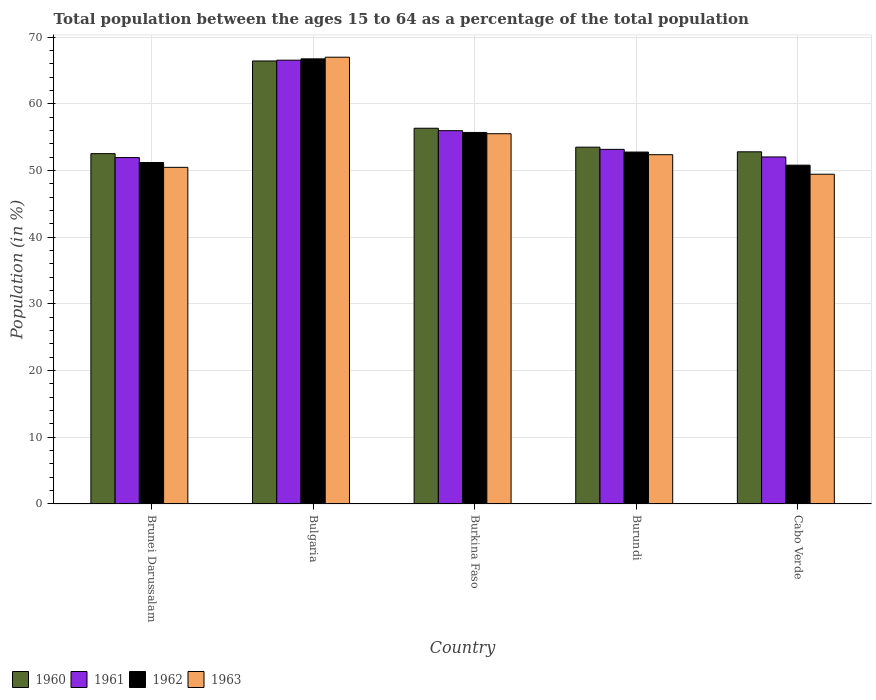How many different coloured bars are there?
Offer a very short reply. 4. Are the number of bars per tick equal to the number of legend labels?
Give a very brief answer. Yes. Are the number of bars on each tick of the X-axis equal?
Make the answer very short. Yes. What is the label of the 4th group of bars from the left?
Offer a very short reply. Burundi. What is the percentage of the population ages 15 to 64 in 1962 in Bulgaria?
Provide a short and direct response. 66.76. Across all countries, what is the maximum percentage of the population ages 15 to 64 in 1960?
Offer a very short reply. 66.44. Across all countries, what is the minimum percentage of the population ages 15 to 64 in 1960?
Offer a very short reply. 52.54. In which country was the percentage of the population ages 15 to 64 in 1962 minimum?
Keep it short and to the point. Cabo Verde. What is the total percentage of the population ages 15 to 64 in 1962 in the graph?
Provide a short and direct response. 277.27. What is the difference between the percentage of the population ages 15 to 64 in 1963 in Burkina Faso and that in Cabo Verde?
Give a very brief answer. 6.07. What is the difference between the percentage of the population ages 15 to 64 in 1963 in Brunei Darussalam and the percentage of the population ages 15 to 64 in 1960 in Burkina Faso?
Keep it short and to the point. -5.86. What is the average percentage of the population ages 15 to 64 in 1960 per country?
Make the answer very short. 56.33. What is the difference between the percentage of the population ages 15 to 64 of/in 1960 and percentage of the population ages 15 to 64 of/in 1963 in Burundi?
Your answer should be compact. 1.13. In how many countries, is the percentage of the population ages 15 to 64 in 1963 greater than 22?
Ensure brevity in your answer.  5. What is the ratio of the percentage of the population ages 15 to 64 in 1960 in Bulgaria to that in Burkina Faso?
Your answer should be very brief. 1.18. What is the difference between the highest and the second highest percentage of the population ages 15 to 64 in 1960?
Your response must be concise. -10.09. What is the difference between the highest and the lowest percentage of the population ages 15 to 64 in 1962?
Give a very brief answer. 15.94. In how many countries, is the percentage of the population ages 15 to 64 in 1963 greater than the average percentage of the population ages 15 to 64 in 1963 taken over all countries?
Keep it short and to the point. 2. Is it the case that in every country, the sum of the percentage of the population ages 15 to 64 in 1960 and percentage of the population ages 15 to 64 in 1963 is greater than the sum of percentage of the population ages 15 to 64 in 1961 and percentage of the population ages 15 to 64 in 1962?
Offer a terse response. No. What does the 1st bar from the left in Cabo Verde represents?
Your answer should be compact. 1960. What does the 3rd bar from the right in Burkina Faso represents?
Ensure brevity in your answer.  1961. Does the graph contain grids?
Your answer should be very brief. Yes. Where does the legend appear in the graph?
Give a very brief answer. Bottom left. How many legend labels are there?
Make the answer very short. 4. What is the title of the graph?
Make the answer very short. Total population between the ages 15 to 64 as a percentage of the total population. Does "1977" appear as one of the legend labels in the graph?
Your response must be concise. No. What is the Population (in %) of 1960 in Brunei Darussalam?
Keep it short and to the point. 52.54. What is the Population (in %) of 1961 in Brunei Darussalam?
Ensure brevity in your answer.  51.95. What is the Population (in %) of 1962 in Brunei Darussalam?
Provide a succinct answer. 51.21. What is the Population (in %) in 1963 in Brunei Darussalam?
Make the answer very short. 50.48. What is the Population (in %) of 1960 in Bulgaria?
Provide a succinct answer. 66.44. What is the Population (in %) in 1961 in Bulgaria?
Your answer should be very brief. 66.56. What is the Population (in %) of 1962 in Bulgaria?
Provide a short and direct response. 66.76. What is the Population (in %) of 1963 in Bulgaria?
Your answer should be compact. 67. What is the Population (in %) in 1960 in Burkina Faso?
Ensure brevity in your answer.  56.35. What is the Population (in %) in 1961 in Burkina Faso?
Make the answer very short. 55.98. What is the Population (in %) in 1962 in Burkina Faso?
Your response must be concise. 55.72. What is the Population (in %) of 1963 in Burkina Faso?
Keep it short and to the point. 55.53. What is the Population (in %) in 1960 in Burundi?
Your answer should be compact. 53.51. What is the Population (in %) of 1961 in Burundi?
Your response must be concise. 53.18. What is the Population (in %) in 1962 in Burundi?
Your response must be concise. 52.78. What is the Population (in %) in 1963 in Burundi?
Ensure brevity in your answer.  52.38. What is the Population (in %) in 1960 in Cabo Verde?
Your answer should be compact. 52.81. What is the Population (in %) of 1961 in Cabo Verde?
Your answer should be very brief. 52.04. What is the Population (in %) in 1962 in Cabo Verde?
Keep it short and to the point. 50.81. What is the Population (in %) of 1963 in Cabo Verde?
Provide a short and direct response. 49.45. Across all countries, what is the maximum Population (in %) in 1960?
Your answer should be very brief. 66.44. Across all countries, what is the maximum Population (in %) in 1961?
Offer a very short reply. 66.56. Across all countries, what is the maximum Population (in %) in 1962?
Your response must be concise. 66.76. Across all countries, what is the maximum Population (in %) in 1963?
Your answer should be compact. 67. Across all countries, what is the minimum Population (in %) in 1960?
Ensure brevity in your answer.  52.54. Across all countries, what is the minimum Population (in %) of 1961?
Your answer should be very brief. 51.95. Across all countries, what is the minimum Population (in %) in 1962?
Provide a succinct answer. 50.81. Across all countries, what is the minimum Population (in %) of 1963?
Offer a terse response. 49.45. What is the total Population (in %) of 1960 in the graph?
Provide a succinct answer. 281.65. What is the total Population (in %) in 1961 in the graph?
Provide a short and direct response. 279.72. What is the total Population (in %) in 1962 in the graph?
Keep it short and to the point. 277.27. What is the total Population (in %) in 1963 in the graph?
Provide a succinct answer. 274.85. What is the difference between the Population (in %) of 1960 in Brunei Darussalam and that in Bulgaria?
Keep it short and to the point. -13.9. What is the difference between the Population (in %) of 1961 in Brunei Darussalam and that in Bulgaria?
Make the answer very short. -14.61. What is the difference between the Population (in %) in 1962 in Brunei Darussalam and that in Bulgaria?
Provide a succinct answer. -15.55. What is the difference between the Population (in %) of 1963 in Brunei Darussalam and that in Bulgaria?
Ensure brevity in your answer.  -16.52. What is the difference between the Population (in %) in 1960 in Brunei Darussalam and that in Burkina Faso?
Make the answer very short. -3.81. What is the difference between the Population (in %) of 1961 in Brunei Darussalam and that in Burkina Faso?
Ensure brevity in your answer.  -4.03. What is the difference between the Population (in %) in 1962 in Brunei Darussalam and that in Burkina Faso?
Offer a terse response. -4.51. What is the difference between the Population (in %) of 1963 in Brunei Darussalam and that in Burkina Faso?
Your answer should be very brief. -5.04. What is the difference between the Population (in %) of 1960 in Brunei Darussalam and that in Burundi?
Give a very brief answer. -0.97. What is the difference between the Population (in %) of 1961 in Brunei Darussalam and that in Burundi?
Your answer should be very brief. -1.23. What is the difference between the Population (in %) in 1962 in Brunei Darussalam and that in Burundi?
Keep it short and to the point. -1.57. What is the difference between the Population (in %) of 1963 in Brunei Darussalam and that in Burundi?
Offer a terse response. -1.9. What is the difference between the Population (in %) of 1960 in Brunei Darussalam and that in Cabo Verde?
Provide a succinct answer. -0.28. What is the difference between the Population (in %) of 1961 in Brunei Darussalam and that in Cabo Verde?
Offer a very short reply. -0.09. What is the difference between the Population (in %) of 1962 in Brunei Darussalam and that in Cabo Verde?
Ensure brevity in your answer.  0.4. What is the difference between the Population (in %) of 1963 in Brunei Darussalam and that in Cabo Verde?
Offer a terse response. 1.03. What is the difference between the Population (in %) of 1960 in Bulgaria and that in Burkina Faso?
Your answer should be compact. 10.09. What is the difference between the Population (in %) of 1961 in Bulgaria and that in Burkina Faso?
Keep it short and to the point. 10.57. What is the difference between the Population (in %) of 1962 in Bulgaria and that in Burkina Faso?
Provide a succinct answer. 11.04. What is the difference between the Population (in %) of 1963 in Bulgaria and that in Burkina Faso?
Your response must be concise. 11.48. What is the difference between the Population (in %) in 1960 in Bulgaria and that in Burundi?
Keep it short and to the point. 12.93. What is the difference between the Population (in %) of 1961 in Bulgaria and that in Burundi?
Provide a short and direct response. 13.38. What is the difference between the Population (in %) of 1962 in Bulgaria and that in Burundi?
Provide a short and direct response. 13.98. What is the difference between the Population (in %) in 1963 in Bulgaria and that in Burundi?
Ensure brevity in your answer.  14.62. What is the difference between the Population (in %) of 1960 in Bulgaria and that in Cabo Verde?
Ensure brevity in your answer.  13.62. What is the difference between the Population (in %) in 1961 in Bulgaria and that in Cabo Verde?
Keep it short and to the point. 14.51. What is the difference between the Population (in %) in 1962 in Bulgaria and that in Cabo Verde?
Offer a terse response. 15.94. What is the difference between the Population (in %) in 1963 in Bulgaria and that in Cabo Verde?
Provide a short and direct response. 17.55. What is the difference between the Population (in %) in 1960 in Burkina Faso and that in Burundi?
Give a very brief answer. 2.84. What is the difference between the Population (in %) in 1961 in Burkina Faso and that in Burundi?
Keep it short and to the point. 2.8. What is the difference between the Population (in %) of 1962 in Burkina Faso and that in Burundi?
Make the answer very short. 2.94. What is the difference between the Population (in %) in 1963 in Burkina Faso and that in Burundi?
Your response must be concise. 3.15. What is the difference between the Population (in %) of 1960 in Burkina Faso and that in Cabo Verde?
Ensure brevity in your answer.  3.53. What is the difference between the Population (in %) in 1961 in Burkina Faso and that in Cabo Verde?
Make the answer very short. 3.94. What is the difference between the Population (in %) of 1962 in Burkina Faso and that in Cabo Verde?
Make the answer very short. 4.91. What is the difference between the Population (in %) in 1963 in Burkina Faso and that in Cabo Verde?
Your response must be concise. 6.07. What is the difference between the Population (in %) in 1960 in Burundi and that in Cabo Verde?
Offer a terse response. 0.7. What is the difference between the Population (in %) in 1961 in Burundi and that in Cabo Verde?
Your answer should be very brief. 1.14. What is the difference between the Population (in %) of 1962 in Burundi and that in Cabo Verde?
Offer a terse response. 1.96. What is the difference between the Population (in %) of 1963 in Burundi and that in Cabo Verde?
Provide a short and direct response. 2.93. What is the difference between the Population (in %) in 1960 in Brunei Darussalam and the Population (in %) in 1961 in Bulgaria?
Your response must be concise. -14.02. What is the difference between the Population (in %) of 1960 in Brunei Darussalam and the Population (in %) of 1962 in Bulgaria?
Give a very brief answer. -14.22. What is the difference between the Population (in %) in 1960 in Brunei Darussalam and the Population (in %) in 1963 in Bulgaria?
Give a very brief answer. -14.46. What is the difference between the Population (in %) of 1961 in Brunei Darussalam and the Population (in %) of 1962 in Bulgaria?
Ensure brevity in your answer.  -14.81. What is the difference between the Population (in %) in 1961 in Brunei Darussalam and the Population (in %) in 1963 in Bulgaria?
Your response must be concise. -15.05. What is the difference between the Population (in %) in 1962 in Brunei Darussalam and the Population (in %) in 1963 in Bulgaria?
Offer a terse response. -15.79. What is the difference between the Population (in %) in 1960 in Brunei Darussalam and the Population (in %) in 1961 in Burkina Faso?
Give a very brief answer. -3.44. What is the difference between the Population (in %) in 1960 in Brunei Darussalam and the Population (in %) in 1962 in Burkina Faso?
Your answer should be very brief. -3.18. What is the difference between the Population (in %) of 1960 in Brunei Darussalam and the Population (in %) of 1963 in Burkina Faso?
Make the answer very short. -2.99. What is the difference between the Population (in %) of 1961 in Brunei Darussalam and the Population (in %) of 1962 in Burkina Faso?
Keep it short and to the point. -3.77. What is the difference between the Population (in %) of 1961 in Brunei Darussalam and the Population (in %) of 1963 in Burkina Faso?
Ensure brevity in your answer.  -3.58. What is the difference between the Population (in %) in 1962 in Brunei Darussalam and the Population (in %) in 1963 in Burkina Faso?
Make the answer very short. -4.32. What is the difference between the Population (in %) of 1960 in Brunei Darussalam and the Population (in %) of 1961 in Burundi?
Provide a succinct answer. -0.64. What is the difference between the Population (in %) of 1960 in Brunei Darussalam and the Population (in %) of 1962 in Burundi?
Keep it short and to the point. -0.24. What is the difference between the Population (in %) of 1960 in Brunei Darussalam and the Population (in %) of 1963 in Burundi?
Your answer should be compact. 0.16. What is the difference between the Population (in %) in 1961 in Brunei Darussalam and the Population (in %) in 1962 in Burundi?
Your answer should be very brief. -0.83. What is the difference between the Population (in %) in 1961 in Brunei Darussalam and the Population (in %) in 1963 in Burundi?
Your answer should be very brief. -0.43. What is the difference between the Population (in %) in 1962 in Brunei Darussalam and the Population (in %) in 1963 in Burundi?
Keep it short and to the point. -1.17. What is the difference between the Population (in %) in 1960 in Brunei Darussalam and the Population (in %) in 1961 in Cabo Verde?
Offer a very short reply. 0.49. What is the difference between the Population (in %) in 1960 in Brunei Darussalam and the Population (in %) in 1962 in Cabo Verde?
Provide a succinct answer. 1.73. What is the difference between the Population (in %) of 1960 in Brunei Darussalam and the Population (in %) of 1963 in Cabo Verde?
Provide a succinct answer. 3.09. What is the difference between the Population (in %) of 1961 in Brunei Darussalam and the Population (in %) of 1962 in Cabo Verde?
Your response must be concise. 1.14. What is the difference between the Population (in %) in 1961 in Brunei Darussalam and the Population (in %) in 1963 in Cabo Verde?
Provide a short and direct response. 2.5. What is the difference between the Population (in %) in 1962 in Brunei Darussalam and the Population (in %) in 1963 in Cabo Verde?
Make the answer very short. 1.76. What is the difference between the Population (in %) of 1960 in Bulgaria and the Population (in %) of 1961 in Burkina Faso?
Offer a terse response. 10.46. What is the difference between the Population (in %) of 1960 in Bulgaria and the Population (in %) of 1962 in Burkina Faso?
Keep it short and to the point. 10.72. What is the difference between the Population (in %) of 1960 in Bulgaria and the Population (in %) of 1963 in Burkina Faso?
Make the answer very short. 10.91. What is the difference between the Population (in %) of 1961 in Bulgaria and the Population (in %) of 1962 in Burkina Faso?
Offer a terse response. 10.84. What is the difference between the Population (in %) of 1961 in Bulgaria and the Population (in %) of 1963 in Burkina Faso?
Your answer should be compact. 11.03. What is the difference between the Population (in %) of 1962 in Bulgaria and the Population (in %) of 1963 in Burkina Faso?
Provide a succinct answer. 11.23. What is the difference between the Population (in %) of 1960 in Bulgaria and the Population (in %) of 1961 in Burundi?
Ensure brevity in your answer.  13.26. What is the difference between the Population (in %) of 1960 in Bulgaria and the Population (in %) of 1962 in Burundi?
Your answer should be compact. 13.66. What is the difference between the Population (in %) in 1960 in Bulgaria and the Population (in %) in 1963 in Burundi?
Ensure brevity in your answer.  14.06. What is the difference between the Population (in %) of 1961 in Bulgaria and the Population (in %) of 1962 in Burundi?
Make the answer very short. 13.78. What is the difference between the Population (in %) of 1961 in Bulgaria and the Population (in %) of 1963 in Burundi?
Your answer should be compact. 14.18. What is the difference between the Population (in %) of 1962 in Bulgaria and the Population (in %) of 1963 in Burundi?
Ensure brevity in your answer.  14.38. What is the difference between the Population (in %) of 1960 in Bulgaria and the Population (in %) of 1961 in Cabo Verde?
Offer a very short reply. 14.39. What is the difference between the Population (in %) in 1960 in Bulgaria and the Population (in %) in 1962 in Cabo Verde?
Your answer should be very brief. 15.63. What is the difference between the Population (in %) in 1960 in Bulgaria and the Population (in %) in 1963 in Cabo Verde?
Keep it short and to the point. 16.99. What is the difference between the Population (in %) of 1961 in Bulgaria and the Population (in %) of 1962 in Cabo Verde?
Your answer should be compact. 15.74. What is the difference between the Population (in %) in 1961 in Bulgaria and the Population (in %) in 1963 in Cabo Verde?
Keep it short and to the point. 17.1. What is the difference between the Population (in %) of 1962 in Bulgaria and the Population (in %) of 1963 in Cabo Verde?
Offer a very short reply. 17.3. What is the difference between the Population (in %) in 1960 in Burkina Faso and the Population (in %) in 1961 in Burundi?
Make the answer very short. 3.17. What is the difference between the Population (in %) of 1960 in Burkina Faso and the Population (in %) of 1962 in Burundi?
Make the answer very short. 3.57. What is the difference between the Population (in %) in 1960 in Burkina Faso and the Population (in %) in 1963 in Burundi?
Provide a succinct answer. 3.97. What is the difference between the Population (in %) in 1961 in Burkina Faso and the Population (in %) in 1962 in Burundi?
Keep it short and to the point. 3.21. What is the difference between the Population (in %) in 1961 in Burkina Faso and the Population (in %) in 1963 in Burundi?
Give a very brief answer. 3.6. What is the difference between the Population (in %) in 1962 in Burkina Faso and the Population (in %) in 1963 in Burundi?
Provide a succinct answer. 3.34. What is the difference between the Population (in %) of 1960 in Burkina Faso and the Population (in %) of 1961 in Cabo Verde?
Make the answer very short. 4.3. What is the difference between the Population (in %) in 1960 in Burkina Faso and the Population (in %) in 1962 in Cabo Verde?
Ensure brevity in your answer.  5.54. What is the difference between the Population (in %) of 1960 in Burkina Faso and the Population (in %) of 1963 in Cabo Verde?
Offer a terse response. 6.9. What is the difference between the Population (in %) in 1961 in Burkina Faso and the Population (in %) in 1962 in Cabo Verde?
Your response must be concise. 5.17. What is the difference between the Population (in %) of 1961 in Burkina Faso and the Population (in %) of 1963 in Cabo Verde?
Keep it short and to the point. 6.53. What is the difference between the Population (in %) of 1962 in Burkina Faso and the Population (in %) of 1963 in Cabo Verde?
Provide a succinct answer. 6.26. What is the difference between the Population (in %) in 1960 in Burundi and the Population (in %) in 1961 in Cabo Verde?
Ensure brevity in your answer.  1.47. What is the difference between the Population (in %) of 1960 in Burundi and the Population (in %) of 1962 in Cabo Verde?
Give a very brief answer. 2.7. What is the difference between the Population (in %) of 1960 in Burundi and the Population (in %) of 1963 in Cabo Verde?
Make the answer very short. 4.06. What is the difference between the Population (in %) of 1961 in Burundi and the Population (in %) of 1962 in Cabo Verde?
Your answer should be very brief. 2.37. What is the difference between the Population (in %) in 1961 in Burundi and the Population (in %) in 1963 in Cabo Verde?
Make the answer very short. 3.73. What is the difference between the Population (in %) of 1962 in Burundi and the Population (in %) of 1963 in Cabo Verde?
Your answer should be very brief. 3.32. What is the average Population (in %) in 1960 per country?
Give a very brief answer. 56.33. What is the average Population (in %) in 1961 per country?
Offer a very short reply. 55.94. What is the average Population (in %) in 1962 per country?
Provide a short and direct response. 55.45. What is the average Population (in %) of 1963 per country?
Make the answer very short. 54.97. What is the difference between the Population (in %) of 1960 and Population (in %) of 1961 in Brunei Darussalam?
Make the answer very short. 0.59. What is the difference between the Population (in %) in 1960 and Population (in %) in 1962 in Brunei Darussalam?
Your answer should be compact. 1.33. What is the difference between the Population (in %) in 1960 and Population (in %) in 1963 in Brunei Darussalam?
Provide a succinct answer. 2.05. What is the difference between the Population (in %) of 1961 and Population (in %) of 1962 in Brunei Darussalam?
Offer a very short reply. 0.74. What is the difference between the Population (in %) in 1961 and Population (in %) in 1963 in Brunei Darussalam?
Make the answer very short. 1.47. What is the difference between the Population (in %) of 1962 and Population (in %) of 1963 in Brunei Darussalam?
Offer a terse response. 0.72. What is the difference between the Population (in %) in 1960 and Population (in %) in 1961 in Bulgaria?
Your answer should be very brief. -0.12. What is the difference between the Population (in %) of 1960 and Population (in %) of 1962 in Bulgaria?
Keep it short and to the point. -0.32. What is the difference between the Population (in %) of 1960 and Population (in %) of 1963 in Bulgaria?
Keep it short and to the point. -0.56. What is the difference between the Population (in %) of 1961 and Population (in %) of 1962 in Bulgaria?
Your answer should be compact. -0.2. What is the difference between the Population (in %) in 1961 and Population (in %) in 1963 in Bulgaria?
Provide a short and direct response. -0.44. What is the difference between the Population (in %) of 1962 and Population (in %) of 1963 in Bulgaria?
Make the answer very short. -0.24. What is the difference between the Population (in %) in 1960 and Population (in %) in 1961 in Burkina Faso?
Make the answer very short. 0.37. What is the difference between the Population (in %) in 1960 and Population (in %) in 1962 in Burkina Faso?
Ensure brevity in your answer.  0.63. What is the difference between the Population (in %) in 1960 and Population (in %) in 1963 in Burkina Faso?
Keep it short and to the point. 0.82. What is the difference between the Population (in %) of 1961 and Population (in %) of 1962 in Burkina Faso?
Provide a succinct answer. 0.26. What is the difference between the Population (in %) of 1961 and Population (in %) of 1963 in Burkina Faso?
Your answer should be compact. 0.46. What is the difference between the Population (in %) in 1962 and Population (in %) in 1963 in Burkina Faso?
Your answer should be very brief. 0.19. What is the difference between the Population (in %) in 1960 and Population (in %) in 1961 in Burundi?
Ensure brevity in your answer.  0.33. What is the difference between the Population (in %) in 1960 and Population (in %) in 1962 in Burundi?
Provide a succinct answer. 0.73. What is the difference between the Population (in %) of 1960 and Population (in %) of 1963 in Burundi?
Make the answer very short. 1.13. What is the difference between the Population (in %) of 1961 and Population (in %) of 1962 in Burundi?
Your answer should be very brief. 0.4. What is the difference between the Population (in %) in 1961 and Population (in %) in 1963 in Burundi?
Give a very brief answer. 0.8. What is the difference between the Population (in %) of 1962 and Population (in %) of 1963 in Burundi?
Offer a very short reply. 0.4. What is the difference between the Population (in %) in 1960 and Population (in %) in 1961 in Cabo Verde?
Your answer should be very brief. 0.77. What is the difference between the Population (in %) in 1960 and Population (in %) in 1962 in Cabo Verde?
Your answer should be compact. 2. What is the difference between the Population (in %) in 1960 and Population (in %) in 1963 in Cabo Verde?
Provide a succinct answer. 3.36. What is the difference between the Population (in %) in 1961 and Population (in %) in 1962 in Cabo Verde?
Provide a succinct answer. 1.23. What is the difference between the Population (in %) in 1961 and Population (in %) in 1963 in Cabo Verde?
Give a very brief answer. 2.59. What is the difference between the Population (in %) in 1962 and Population (in %) in 1963 in Cabo Verde?
Give a very brief answer. 1.36. What is the ratio of the Population (in %) in 1960 in Brunei Darussalam to that in Bulgaria?
Provide a short and direct response. 0.79. What is the ratio of the Population (in %) of 1961 in Brunei Darussalam to that in Bulgaria?
Offer a very short reply. 0.78. What is the ratio of the Population (in %) of 1962 in Brunei Darussalam to that in Bulgaria?
Offer a very short reply. 0.77. What is the ratio of the Population (in %) in 1963 in Brunei Darussalam to that in Bulgaria?
Offer a very short reply. 0.75. What is the ratio of the Population (in %) in 1960 in Brunei Darussalam to that in Burkina Faso?
Offer a terse response. 0.93. What is the ratio of the Population (in %) of 1961 in Brunei Darussalam to that in Burkina Faso?
Make the answer very short. 0.93. What is the ratio of the Population (in %) in 1962 in Brunei Darussalam to that in Burkina Faso?
Your response must be concise. 0.92. What is the ratio of the Population (in %) of 1963 in Brunei Darussalam to that in Burkina Faso?
Your answer should be very brief. 0.91. What is the ratio of the Population (in %) in 1960 in Brunei Darussalam to that in Burundi?
Your answer should be compact. 0.98. What is the ratio of the Population (in %) in 1961 in Brunei Darussalam to that in Burundi?
Keep it short and to the point. 0.98. What is the ratio of the Population (in %) in 1962 in Brunei Darussalam to that in Burundi?
Keep it short and to the point. 0.97. What is the ratio of the Population (in %) of 1963 in Brunei Darussalam to that in Burundi?
Your response must be concise. 0.96. What is the ratio of the Population (in %) of 1961 in Brunei Darussalam to that in Cabo Verde?
Keep it short and to the point. 1. What is the ratio of the Population (in %) in 1962 in Brunei Darussalam to that in Cabo Verde?
Provide a short and direct response. 1.01. What is the ratio of the Population (in %) in 1963 in Brunei Darussalam to that in Cabo Verde?
Provide a short and direct response. 1.02. What is the ratio of the Population (in %) in 1960 in Bulgaria to that in Burkina Faso?
Keep it short and to the point. 1.18. What is the ratio of the Population (in %) of 1961 in Bulgaria to that in Burkina Faso?
Offer a very short reply. 1.19. What is the ratio of the Population (in %) in 1962 in Bulgaria to that in Burkina Faso?
Make the answer very short. 1.2. What is the ratio of the Population (in %) of 1963 in Bulgaria to that in Burkina Faso?
Provide a succinct answer. 1.21. What is the ratio of the Population (in %) in 1960 in Bulgaria to that in Burundi?
Give a very brief answer. 1.24. What is the ratio of the Population (in %) in 1961 in Bulgaria to that in Burundi?
Your answer should be compact. 1.25. What is the ratio of the Population (in %) of 1962 in Bulgaria to that in Burundi?
Your answer should be compact. 1.26. What is the ratio of the Population (in %) in 1963 in Bulgaria to that in Burundi?
Give a very brief answer. 1.28. What is the ratio of the Population (in %) of 1960 in Bulgaria to that in Cabo Verde?
Make the answer very short. 1.26. What is the ratio of the Population (in %) in 1961 in Bulgaria to that in Cabo Verde?
Keep it short and to the point. 1.28. What is the ratio of the Population (in %) in 1962 in Bulgaria to that in Cabo Verde?
Give a very brief answer. 1.31. What is the ratio of the Population (in %) in 1963 in Bulgaria to that in Cabo Verde?
Provide a short and direct response. 1.35. What is the ratio of the Population (in %) in 1960 in Burkina Faso to that in Burundi?
Keep it short and to the point. 1.05. What is the ratio of the Population (in %) in 1961 in Burkina Faso to that in Burundi?
Your response must be concise. 1.05. What is the ratio of the Population (in %) in 1962 in Burkina Faso to that in Burundi?
Provide a succinct answer. 1.06. What is the ratio of the Population (in %) in 1963 in Burkina Faso to that in Burundi?
Offer a very short reply. 1.06. What is the ratio of the Population (in %) of 1960 in Burkina Faso to that in Cabo Verde?
Give a very brief answer. 1.07. What is the ratio of the Population (in %) in 1961 in Burkina Faso to that in Cabo Verde?
Give a very brief answer. 1.08. What is the ratio of the Population (in %) of 1962 in Burkina Faso to that in Cabo Verde?
Provide a succinct answer. 1.1. What is the ratio of the Population (in %) of 1963 in Burkina Faso to that in Cabo Verde?
Keep it short and to the point. 1.12. What is the ratio of the Population (in %) in 1960 in Burundi to that in Cabo Verde?
Give a very brief answer. 1.01. What is the ratio of the Population (in %) in 1961 in Burundi to that in Cabo Verde?
Your answer should be very brief. 1.02. What is the ratio of the Population (in %) of 1962 in Burundi to that in Cabo Verde?
Give a very brief answer. 1.04. What is the ratio of the Population (in %) in 1963 in Burundi to that in Cabo Verde?
Ensure brevity in your answer.  1.06. What is the difference between the highest and the second highest Population (in %) of 1960?
Offer a very short reply. 10.09. What is the difference between the highest and the second highest Population (in %) in 1961?
Offer a terse response. 10.57. What is the difference between the highest and the second highest Population (in %) in 1962?
Offer a very short reply. 11.04. What is the difference between the highest and the second highest Population (in %) in 1963?
Make the answer very short. 11.48. What is the difference between the highest and the lowest Population (in %) of 1960?
Offer a very short reply. 13.9. What is the difference between the highest and the lowest Population (in %) in 1961?
Give a very brief answer. 14.61. What is the difference between the highest and the lowest Population (in %) of 1962?
Give a very brief answer. 15.94. What is the difference between the highest and the lowest Population (in %) of 1963?
Offer a very short reply. 17.55. 